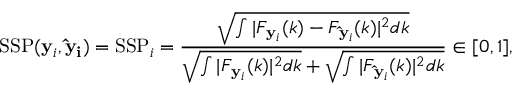<formula> <loc_0><loc_0><loc_500><loc_500>S S P ( y _ { i } , \hat { y } _ { i } ) = S S P _ { i } = \frac { \sqrt { \int | F _ { y _ { i } } ( k ) - F _ { \hat { y } _ { i } } ( k ) | ^ { 2 } d k } } { \sqrt { \int | F _ { y _ { i } } ( k ) | ^ { 2 } d k } + \sqrt { \int | F _ { \hat { y } _ { i } } ( k ) | ^ { 2 } d k } } \in [ 0 , 1 ] ,</formula> 